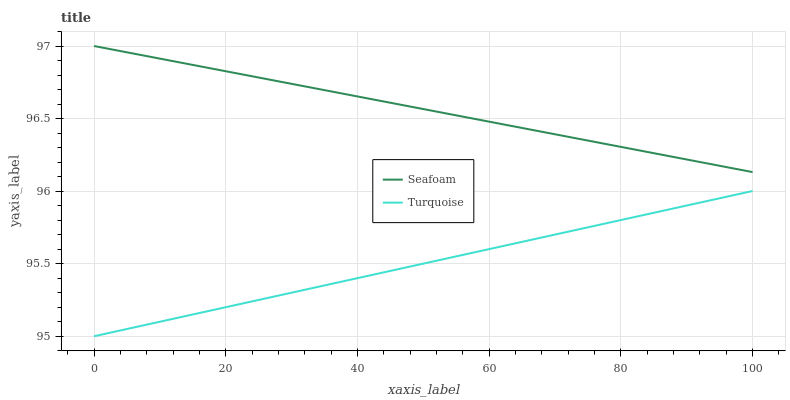Does Seafoam have the minimum area under the curve?
Answer yes or no. No. Is Seafoam the smoothest?
Answer yes or no. No. Does Seafoam have the lowest value?
Answer yes or no. No. Is Turquoise less than Seafoam?
Answer yes or no. Yes. Is Seafoam greater than Turquoise?
Answer yes or no. Yes. Does Turquoise intersect Seafoam?
Answer yes or no. No. 